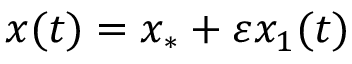Convert formula to latex. <formula><loc_0><loc_0><loc_500><loc_500>x ( t ) = x _ { * } + \varepsilon x _ { 1 } ( t )</formula> 